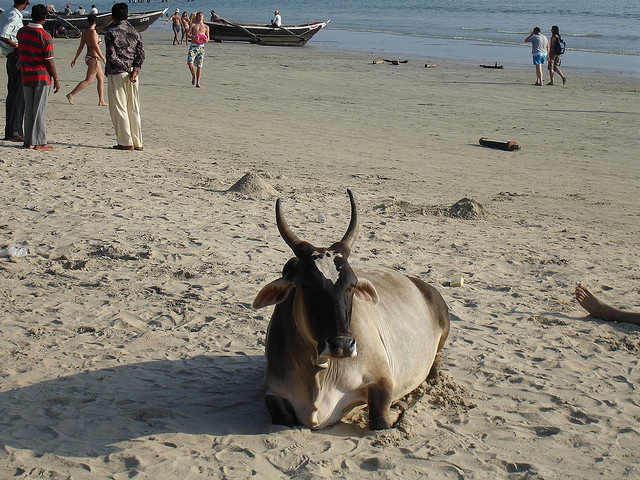Describe the objects in this image and their specific colors. I can see cow in gray, black, and tan tones, people in gray, black, and darkgray tones, people in gray, black, maroon, and darkgray tones, people in gray, black, darkgray, and lightgray tones, and boat in gray and black tones in this image. 